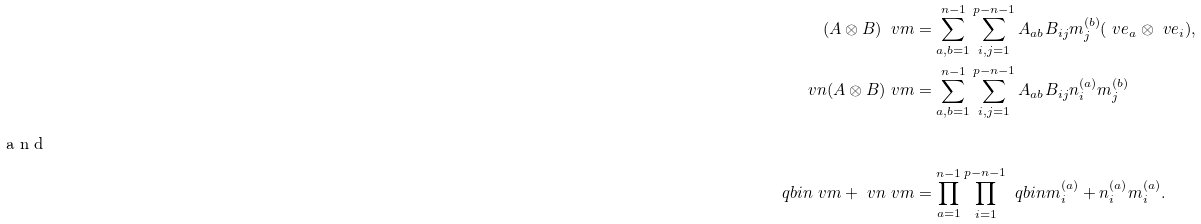<formula> <loc_0><loc_0><loc_500><loc_500>( A \otimes B ) \ v m & = \sum _ { a , b = 1 } ^ { n - 1 } \sum _ { i , j = 1 } ^ { p - n - 1 } A _ { a b } B _ { i j } m _ { j } ^ { ( b ) } ( \ v e _ { a } \otimes \ v e _ { i } ) , \\ \ v n ( A \otimes B ) \ v m & = \sum _ { a , b = 1 } ^ { n - 1 } \sum _ { i , j = 1 } ^ { p - n - 1 } A _ { a b } B _ { i j } n _ { i } ^ { ( a ) } m _ { j } ^ { ( b ) } \\ \intertext { a n d } \ q b i n { \ v m + \ v n } { \ v m } & = \prod _ { a = 1 } ^ { n - 1 } \prod _ { i = 1 } ^ { p - n - 1 } \ q b i n { m _ { i } ^ { ( a ) } + n _ { i } ^ { ( a ) } } { m _ { i } ^ { ( a ) } } .</formula> 